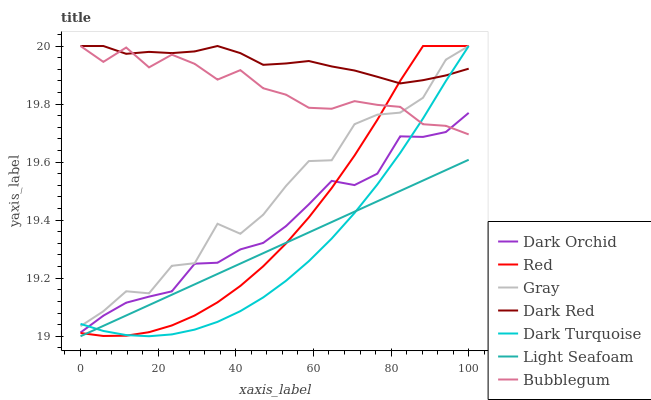Does Dark Turquoise have the minimum area under the curve?
Answer yes or no. Yes. Does Dark Red have the maximum area under the curve?
Answer yes or no. Yes. Does Dark Orchid have the minimum area under the curve?
Answer yes or no. No. Does Dark Orchid have the maximum area under the curve?
Answer yes or no. No. Is Light Seafoam the smoothest?
Answer yes or no. Yes. Is Gray the roughest?
Answer yes or no. Yes. Is Dark Turquoise the smoothest?
Answer yes or no. No. Is Dark Turquoise the roughest?
Answer yes or no. No. Does Light Seafoam have the lowest value?
Answer yes or no. Yes. Does Dark Turquoise have the lowest value?
Answer yes or no. No. Does Red have the highest value?
Answer yes or no. Yes. Does Dark Orchid have the highest value?
Answer yes or no. No. Is Dark Orchid less than Dark Red?
Answer yes or no. Yes. Is Dark Orchid greater than Light Seafoam?
Answer yes or no. Yes. Does Gray intersect Bubblegum?
Answer yes or no. Yes. Is Gray less than Bubblegum?
Answer yes or no. No. Is Gray greater than Bubblegum?
Answer yes or no. No. Does Dark Orchid intersect Dark Red?
Answer yes or no. No. 